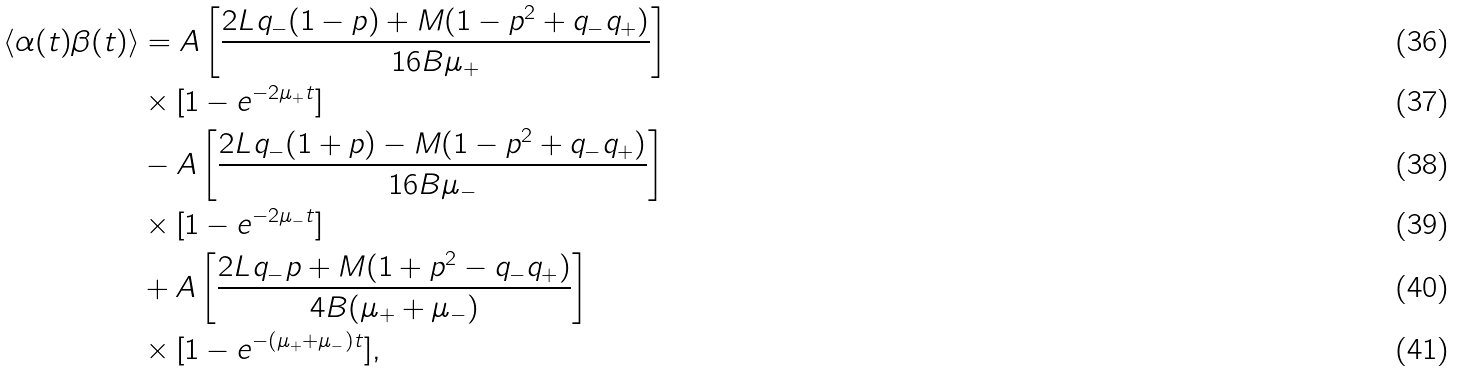<formula> <loc_0><loc_0><loc_500><loc_500>\langle \alpha ( t ) \beta ( t ) \rangle & = A \left [ \frac { 2 L q _ { - } ( 1 - p ) + M ( 1 - p ^ { 2 } + q _ { - } q _ { + } ) } { 1 6 B \mu _ { + } } \right ] \\ & \times [ 1 - e ^ { - 2 \mu _ { + } t } ] \\ & - A \left [ \frac { 2 L q _ { - } ( 1 + p ) - M ( 1 - p ^ { 2 } + q _ { - } q _ { + } ) } { 1 6 B \mu _ { - } } \right ] \\ & \times [ 1 - e ^ { - 2 \mu _ { - } t } ] \\ & + A \left [ \frac { 2 L q _ { - } p + M ( 1 + p ^ { 2 } - q _ { - } q _ { + } ) } { 4 B ( \mu _ { + } + \mu _ { - } ) } \right ] \\ & \times [ 1 - e ^ { - ( \mu _ { + } + \mu _ { - } ) t } ] ,</formula> 